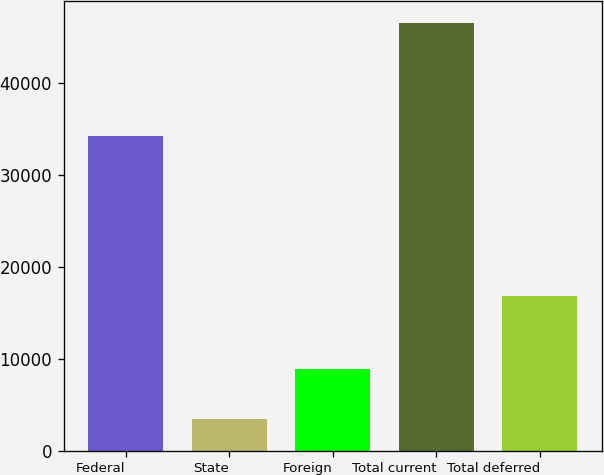Convert chart. <chart><loc_0><loc_0><loc_500><loc_500><bar_chart><fcel>Federal<fcel>State<fcel>Foreign<fcel>Total current<fcel>Total deferred<nl><fcel>34320<fcel>3436<fcel>8858<fcel>46614<fcel>16869<nl></chart> 